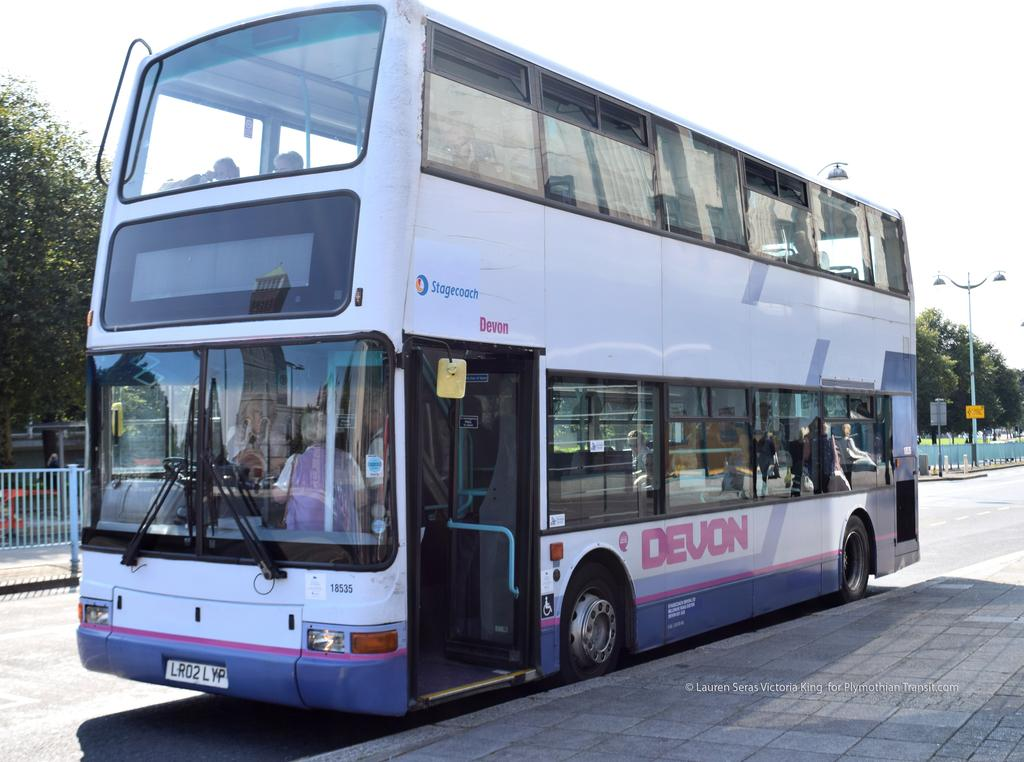<image>
Offer a succinct explanation of the picture presented. A double decker bus from Devon sits with an open door by the sidewalk. 